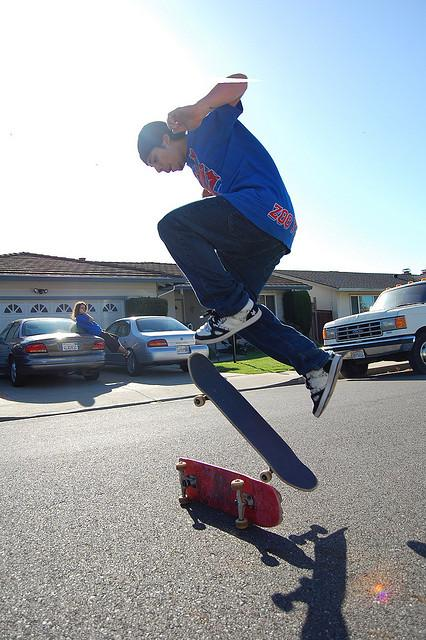What type of skateboarding would this be considered?

Choices:
A) park
B) street
C) vert
D) big air street 